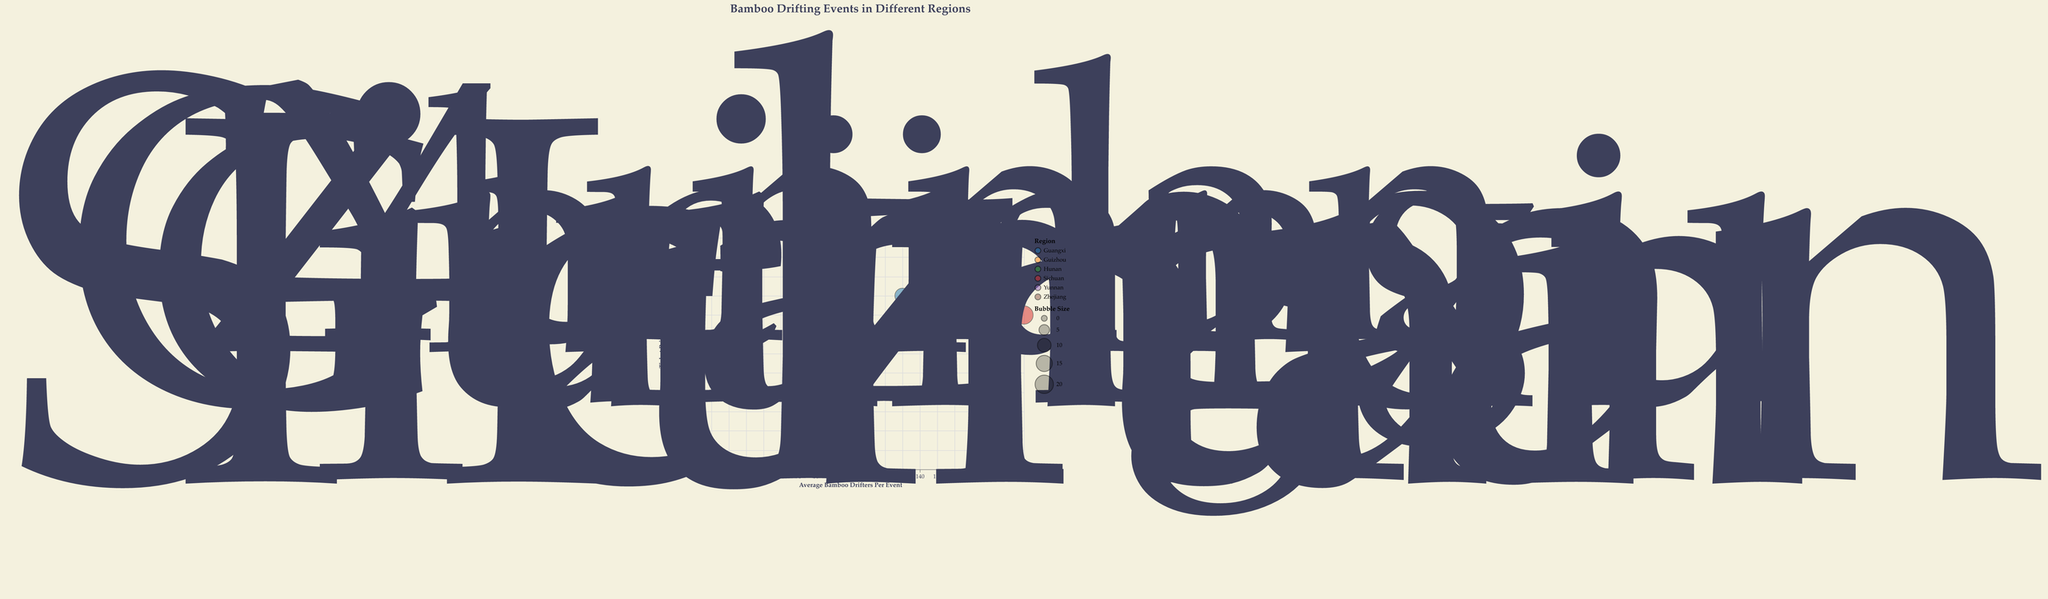What's the title of the chart? The title of the chart is displayed at the top and reads "Bamboo Drifting Events in Different Regions".
Answer: Bamboo Drifting Events in Different Regions Which region has the highest average number of bamboo drifters per event? The region with the highest average number of bamboo drifters per event is represented by the bubble farthest to the right on the x-axis. The bubble representing Sichuan has the highest average number of bamboo drifters per event at 200.
Answer: Sichuan Which region has the most expensive average ticket price? The region with the most expensive average ticket price is represented by the bubble highest on the y-axis. Yunnan has the most expensive average ticket price at $12.
Answer: Yunnan How many regions are represented in the chart? Each bubble represents one region, and there are unique colors for each region. Counting the bubbles, we see there are six regions represented.
Answer: 6 Comparing Guizhou and Hunan, which region has more average bamboo drifters per event? Compare the x-axis positions of the bubbles representing Guizhou and Hunan. Guizhou has an average of 150 bamboo drifters, and Hunan has an average of 180. Therefore, Hunan has more average bamboo drifters per event.
Answer: Hunan Which region has the smallest bubble size? Bubble size corresponds to the given "Bubble Size" field, which represents how large the bubble appears. The Zhejiang region has the smallest bubble size of 11.
Answer: Zhejiang What is the average ticket price for the Zhuang March 3rd Festival? The Zhuang March 3rd Festival is marked on the chart for the Guangxi region. The average ticket price for this festival is listed as $9.
Answer: 9 Which region has the least expensive average ticket price? The region with the least expensive average ticket price has the bubble lowest on the y-axis. Hunan has the least expensive average ticket price at $7.
Answer: Hunan What is the average difference in ticket prices between the most expensive and the least expensive regions? The most expensive average ticket price is in Yunnan at $12, and the least expensive is in Hunan at $7. The difference is calculated as $12 - $7 = $5.
Answer: $5 What is the relationship between bubble size and average bamboo drifters per event? To observe the relationship, look at how the bubble sizes and their x-axis positions vary. Generally, larger bubbles seem to have a higher average number of bamboo drifters. For example, Sichuan has the largest bubble and the highest number of drifters.
Answer: Larger bubbles generally correspond to higher average bamboo drifters per event 